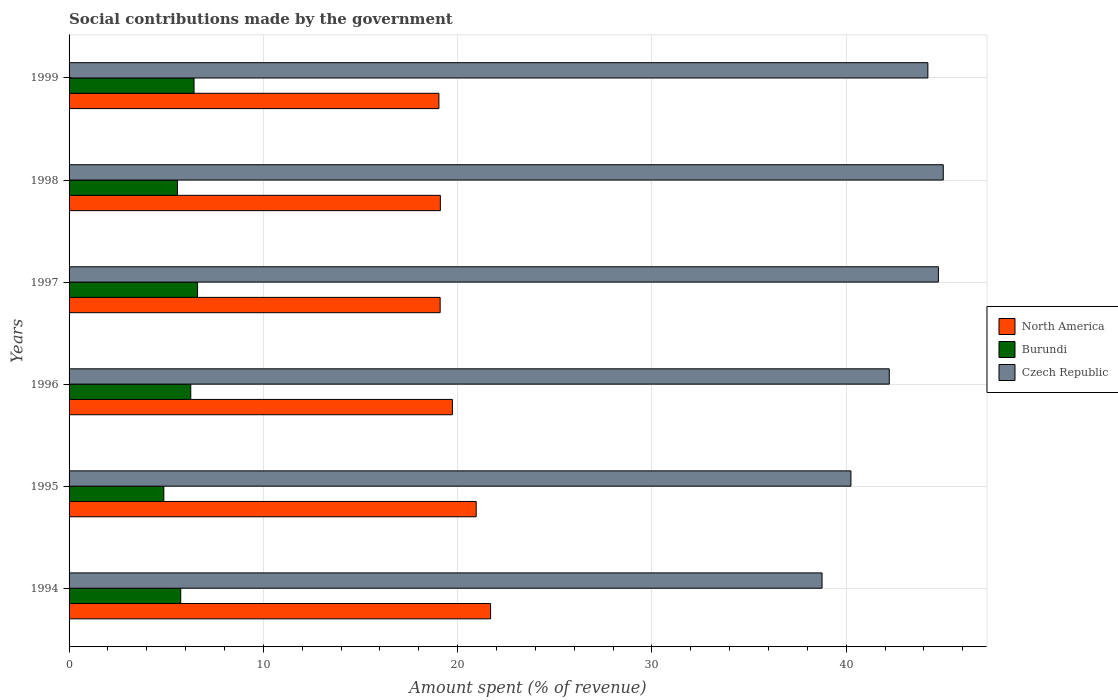How many different coloured bars are there?
Ensure brevity in your answer.  3. How many groups of bars are there?
Offer a very short reply. 6. Are the number of bars per tick equal to the number of legend labels?
Provide a succinct answer. Yes. What is the label of the 6th group of bars from the top?
Offer a terse response. 1994. In how many cases, is the number of bars for a given year not equal to the number of legend labels?
Keep it short and to the point. 0. What is the amount spent (in %) on social contributions in North America in 1996?
Ensure brevity in your answer.  19.73. Across all years, what is the maximum amount spent (in %) on social contributions in North America?
Your response must be concise. 21.69. Across all years, what is the minimum amount spent (in %) on social contributions in Czech Republic?
Provide a short and direct response. 38.75. In which year was the amount spent (in %) on social contributions in North America maximum?
Offer a terse response. 1994. In which year was the amount spent (in %) on social contributions in Czech Republic minimum?
Make the answer very short. 1994. What is the total amount spent (in %) on social contributions in Czech Republic in the graph?
Ensure brevity in your answer.  255.15. What is the difference between the amount spent (in %) on social contributions in Burundi in 1994 and that in 1996?
Your response must be concise. -0.52. What is the difference between the amount spent (in %) on social contributions in Czech Republic in 1996 and the amount spent (in %) on social contributions in Burundi in 1997?
Make the answer very short. 35.6. What is the average amount spent (in %) on social contributions in Burundi per year?
Your response must be concise. 5.92. In the year 1999, what is the difference between the amount spent (in %) on social contributions in Burundi and amount spent (in %) on social contributions in Czech Republic?
Offer a very short reply. -37.77. In how many years, is the amount spent (in %) on social contributions in Czech Republic greater than 24 %?
Make the answer very short. 6. What is the ratio of the amount spent (in %) on social contributions in Burundi in 1994 to that in 1996?
Your response must be concise. 0.92. Is the amount spent (in %) on social contributions in Burundi in 1994 less than that in 1996?
Provide a succinct answer. Yes. What is the difference between the highest and the second highest amount spent (in %) on social contributions in Burundi?
Your response must be concise. 0.18. What is the difference between the highest and the lowest amount spent (in %) on social contributions in Czech Republic?
Provide a short and direct response. 6.24. What does the 1st bar from the top in 1999 represents?
Provide a short and direct response. Czech Republic. Is it the case that in every year, the sum of the amount spent (in %) on social contributions in Burundi and amount spent (in %) on social contributions in North America is greater than the amount spent (in %) on social contributions in Czech Republic?
Provide a succinct answer. No. How many years are there in the graph?
Offer a terse response. 6. What is the difference between two consecutive major ticks on the X-axis?
Provide a short and direct response. 10. Are the values on the major ticks of X-axis written in scientific E-notation?
Give a very brief answer. No. Does the graph contain any zero values?
Offer a terse response. No. Does the graph contain grids?
Ensure brevity in your answer.  Yes. What is the title of the graph?
Provide a succinct answer. Social contributions made by the government. Does "Dominican Republic" appear as one of the legend labels in the graph?
Your answer should be compact. No. What is the label or title of the X-axis?
Make the answer very short. Amount spent (% of revenue). What is the label or title of the Y-axis?
Your answer should be compact. Years. What is the Amount spent (% of revenue) of North America in 1994?
Your answer should be compact. 21.69. What is the Amount spent (% of revenue) in Burundi in 1994?
Ensure brevity in your answer.  5.75. What is the Amount spent (% of revenue) of Czech Republic in 1994?
Your response must be concise. 38.75. What is the Amount spent (% of revenue) of North America in 1995?
Offer a very short reply. 20.95. What is the Amount spent (% of revenue) of Burundi in 1995?
Keep it short and to the point. 4.88. What is the Amount spent (% of revenue) of Czech Republic in 1995?
Provide a short and direct response. 40.24. What is the Amount spent (% of revenue) of North America in 1996?
Keep it short and to the point. 19.73. What is the Amount spent (% of revenue) of Burundi in 1996?
Your answer should be compact. 6.26. What is the Amount spent (% of revenue) in Czech Republic in 1996?
Your response must be concise. 42.22. What is the Amount spent (% of revenue) of North America in 1997?
Your answer should be compact. 19.1. What is the Amount spent (% of revenue) in Burundi in 1997?
Keep it short and to the point. 6.61. What is the Amount spent (% of revenue) in Czech Republic in 1997?
Provide a short and direct response. 44.74. What is the Amount spent (% of revenue) in North America in 1998?
Your answer should be very brief. 19.11. What is the Amount spent (% of revenue) of Burundi in 1998?
Offer a very short reply. 5.58. What is the Amount spent (% of revenue) of Czech Republic in 1998?
Your response must be concise. 44.99. What is the Amount spent (% of revenue) in North America in 1999?
Provide a succinct answer. 19.03. What is the Amount spent (% of revenue) of Burundi in 1999?
Your answer should be compact. 6.43. What is the Amount spent (% of revenue) of Czech Republic in 1999?
Provide a short and direct response. 44.2. Across all years, what is the maximum Amount spent (% of revenue) in North America?
Keep it short and to the point. 21.69. Across all years, what is the maximum Amount spent (% of revenue) in Burundi?
Offer a terse response. 6.61. Across all years, what is the maximum Amount spent (% of revenue) in Czech Republic?
Offer a terse response. 44.99. Across all years, what is the minimum Amount spent (% of revenue) of North America?
Keep it short and to the point. 19.03. Across all years, what is the minimum Amount spent (% of revenue) of Burundi?
Your response must be concise. 4.88. Across all years, what is the minimum Amount spent (% of revenue) in Czech Republic?
Offer a terse response. 38.75. What is the total Amount spent (% of revenue) in North America in the graph?
Your answer should be very brief. 119.62. What is the total Amount spent (% of revenue) in Burundi in the graph?
Make the answer very short. 35.51. What is the total Amount spent (% of revenue) of Czech Republic in the graph?
Ensure brevity in your answer.  255.15. What is the difference between the Amount spent (% of revenue) in North America in 1994 and that in 1995?
Make the answer very short. 0.74. What is the difference between the Amount spent (% of revenue) in Burundi in 1994 and that in 1995?
Provide a short and direct response. 0.87. What is the difference between the Amount spent (% of revenue) in Czech Republic in 1994 and that in 1995?
Provide a succinct answer. -1.49. What is the difference between the Amount spent (% of revenue) of North America in 1994 and that in 1996?
Offer a terse response. 1.97. What is the difference between the Amount spent (% of revenue) of Burundi in 1994 and that in 1996?
Provide a succinct answer. -0.52. What is the difference between the Amount spent (% of revenue) in Czech Republic in 1994 and that in 1996?
Keep it short and to the point. -3.46. What is the difference between the Amount spent (% of revenue) in North America in 1994 and that in 1997?
Offer a terse response. 2.59. What is the difference between the Amount spent (% of revenue) in Burundi in 1994 and that in 1997?
Provide a succinct answer. -0.87. What is the difference between the Amount spent (% of revenue) of Czech Republic in 1994 and that in 1997?
Ensure brevity in your answer.  -5.99. What is the difference between the Amount spent (% of revenue) in North America in 1994 and that in 1998?
Keep it short and to the point. 2.58. What is the difference between the Amount spent (% of revenue) of Burundi in 1994 and that in 1998?
Keep it short and to the point. 0.17. What is the difference between the Amount spent (% of revenue) in Czech Republic in 1994 and that in 1998?
Your answer should be very brief. -6.24. What is the difference between the Amount spent (% of revenue) in North America in 1994 and that in 1999?
Make the answer very short. 2.66. What is the difference between the Amount spent (% of revenue) of Burundi in 1994 and that in 1999?
Your response must be concise. -0.68. What is the difference between the Amount spent (% of revenue) of Czech Republic in 1994 and that in 1999?
Provide a short and direct response. -5.45. What is the difference between the Amount spent (% of revenue) in North America in 1995 and that in 1996?
Keep it short and to the point. 1.23. What is the difference between the Amount spent (% of revenue) of Burundi in 1995 and that in 1996?
Offer a terse response. -1.39. What is the difference between the Amount spent (% of revenue) of Czech Republic in 1995 and that in 1996?
Offer a very short reply. -1.97. What is the difference between the Amount spent (% of revenue) of North America in 1995 and that in 1997?
Provide a succinct answer. 1.86. What is the difference between the Amount spent (% of revenue) in Burundi in 1995 and that in 1997?
Ensure brevity in your answer.  -1.74. What is the difference between the Amount spent (% of revenue) in Czech Republic in 1995 and that in 1997?
Give a very brief answer. -4.5. What is the difference between the Amount spent (% of revenue) in North America in 1995 and that in 1998?
Offer a very short reply. 1.85. What is the difference between the Amount spent (% of revenue) of Burundi in 1995 and that in 1998?
Provide a succinct answer. -0.7. What is the difference between the Amount spent (% of revenue) of Czech Republic in 1995 and that in 1998?
Your response must be concise. -4.75. What is the difference between the Amount spent (% of revenue) of North America in 1995 and that in 1999?
Your response must be concise. 1.92. What is the difference between the Amount spent (% of revenue) in Burundi in 1995 and that in 1999?
Ensure brevity in your answer.  -1.56. What is the difference between the Amount spent (% of revenue) of Czech Republic in 1995 and that in 1999?
Provide a short and direct response. -3.96. What is the difference between the Amount spent (% of revenue) of North America in 1996 and that in 1997?
Offer a very short reply. 0.63. What is the difference between the Amount spent (% of revenue) of Burundi in 1996 and that in 1997?
Your answer should be compact. -0.35. What is the difference between the Amount spent (% of revenue) of Czech Republic in 1996 and that in 1997?
Your answer should be very brief. -2.53. What is the difference between the Amount spent (% of revenue) in North America in 1996 and that in 1998?
Ensure brevity in your answer.  0.62. What is the difference between the Amount spent (% of revenue) of Burundi in 1996 and that in 1998?
Your answer should be very brief. 0.68. What is the difference between the Amount spent (% of revenue) in Czech Republic in 1996 and that in 1998?
Make the answer very short. -2.78. What is the difference between the Amount spent (% of revenue) in North America in 1996 and that in 1999?
Give a very brief answer. 0.69. What is the difference between the Amount spent (% of revenue) in Burundi in 1996 and that in 1999?
Offer a very short reply. -0.17. What is the difference between the Amount spent (% of revenue) of Czech Republic in 1996 and that in 1999?
Provide a short and direct response. -1.99. What is the difference between the Amount spent (% of revenue) of North America in 1997 and that in 1998?
Keep it short and to the point. -0.01. What is the difference between the Amount spent (% of revenue) of Burundi in 1997 and that in 1998?
Provide a succinct answer. 1.03. What is the difference between the Amount spent (% of revenue) in Czech Republic in 1997 and that in 1998?
Offer a terse response. -0.25. What is the difference between the Amount spent (% of revenue) of North America in 1997 and that in 1999?
Keep it short and to the point. 0.06. What is the difference between the Amount spent (% of revenue) of Burundi in 1997 and that in 1999?
Your response must be concise. 0.18. What is the difference between the Amount spent (% of revenue) in Czech Republic in 1997 and that in 1999?
Provide a succinct answer. 0.54. What is the difference between the Amount spent (% of revenue) in North America in 1998 and that in 1999?
Ensure brevity in your answer.  0.07. What is the difference between the Amount spent (% of revenue) of Burundi in 1998 and that in 1999?
Offer a terse response. -0.85. What is the difference between the Amount spent (% of revenue) in Czech Republic in 1998 and that in 1999?
Your response must be concise. 0.79. What is the difference between the Amount spent (% of revenue) in North America in 1994 and the Amount spent (% of revenue) in Burundi in 1995?
Keep it short and to the point. 16.82. What is the difference between the Amount spent (% of revenue) in North America in 1994 and the Amount spent (% of revenue) in Czech Republic in 1995?
Ensure brevity in your answer.  -18.55. What is the difference between the Amount spent (% of revenue) of Burundi in 1994 and the Amount spent (% of revenue) of Czech Republic in 1995?
Keep it short and to the point. -34.49. What is the difference between the Amount spent (% of revenue) in North America in 1994 and the Amount spent (% of revenue) in Burundi in 1996?
Give a very brief answer. 15.43. What is the difference between the Amount spent (% of revenue) in North America in 1994 and the Amount spent (% of revenue) in Czech Republic in 1996?
Offer a very short reply. -20.52. What is the difference between the Amount spent (% of revenue) in Burundi in 1994 and the Amount spent (% of revenue) in Czech Republic in 1996?
Ensure brevity in your answer.  -36.47. What is the difference between the Amount spent (% of revenue) in North America in 1994 and the Amount spent (% of revenue) in Burundi in 1997?
Your answer should be very brief. 15.08. What is the difference between the Amount spent (% of revenue) of North America in 1994 and the Amount spent (% of revenue) of Czech Republic in 1997?
Provide a succinct answer. -23.05. What is the difference between the Amount spent (% of revenue) of Burundi in 1994 and the Amount spent (% of revenue) of Czech Republic in 1997?
Your response must be concise. -39. What is the difference between the Amount spent (% of revenue) of North America in 1994 and the Amount spent (% of revenue) of Burundi in 1998?
Ensure brevity in your answer.  16.12. What is the difference between the Amount spent (% of revenue) in North America in 1994 and the Amount spent (% of revenue) in Czech Republic in 1998?
Give a very brief answer. -23.3. What is the difference between the Amount spent (% of revenue) of Burundi in 1994 and the Amount spent (% of revenue) of Czech Republic in 1998?
Give a very brief answer. -39.25. What is the difference between the Amount spent (% of revenue) of North America in 1994 and the Amount spent (% of revenue) of Burundi in 1999?
Give a very brief answer. 15.26. What is the difference between the Amount spent (% of revenue) of North America in 1994 and the Amount spent (% of revenue) of Czech Republic in 1999?
Your answer should be compact. -22.51. What is the difference between the Amount spent (% of revenue) in Burundi in 1994 and the Amount spent (% of revenue) in Czech Republic in 1999?
Offer a very short reply. -38.45. What is the difference between the Amount spent (% of revenue) in North America in 1995 and the Amount spent (% of revenue) in Burundi in 1996?
Ensure brevity in your answer.  14.69. What is the difference between the Amount spent (% of revenue) of North America in 1995 and the Amount spent (% of revenue) of Czech Republic in 1996?
Give a very brief answer. -21.26. What is the difference between the Amount spent (% of revenue) of Burundi in 1995 and the Amount spent (% of revenue) of Czech Republic in 1996?
Make the answer very short. -37.34. What is the difference between the Amount spent (% of revenue) in North America in 1995 and the Amount spent (% of revenue) in Burundi in 1997?
Ensure brevity in your answer.  14.34. What is the difference between the Amount spent (% of revenue) of North America in 1995 and the Amount spent (% of revenue) of Czech Republic in 1997?
Your response must be concise. -23.79. What is the difference between the Amount spent (% of revenue) in Burundi in 1995 and the Amount spent (% of revenue) in Czech Republic in 1997?
Give a very brief answer. -39.87. What is the difference between the Amount spent (% of revenue) of North America in 1995 and the Amount spent (% of revenue) of Burundi in 1998?
Provide a short and direct response. 15.38. What is the difference between the Amount spent (% of revenue) of North America in 1995 and the Amount spent (% of revenue) of Czech Republic in 1998?
Provide a short and direct response. -24.04. What is the difference between the Amount spent (% of revenue) of Burundi in 1995 and the Amount spent (% of revenue) of Czech Republic in 1998?
Provide a succinct answer. -40.12. What is the difference between the Amount spent (% of revenue) of North America in 1995 and the Amount spent (% of revenue) of Burundi in 1999?
Offer a very short reply. 14.52. What is the difference between the Amount spent (% of revenue) of North America in 1995 and the Amount spent (% of revenue) of Czech Republic in 1999?
Your response must be concise. -23.25. What is the difference between the Amount spent (% of revenue) of Burundi in 1995 and the Amount spent (% of revenue) of Czech Republic in 1999?
Offer a terse response. -39.32. What is the difference between the Amount spent (% of revenue) in North America in 1996 and the Amount spent (% of revenue) in Burundi in 1997?
Keep it short and to the point. 13.12. What is the difference between the Amount spent (% of revenue) of North America in 1996 and the Amount spent (% of revenue) of Czech Republic in 1997?
Your response must be concise. -25.01. What is the difference between the Amount spent (% of revenue) of Burundi in 1996 and the Amount spent (% of revenue) of Czech Republic in 1997?
Offer a terse response. -38.48. What is the difference between the Amount spent (% of revenue) of North America in 1996 and the Amount spent (% of revenue) of Burundi in 1998?
Your answer should be compact. 14.15. What is the difference between the Amount spent (% of revenue) of North America in 1996 and the Amount spent (% of revenue) of Czech Republic in 1998?
Your answer should be very brief. -25.26. What is the difference between the Amount spent (% of revenue) of Burundi in 1996 and the Amount spent (% of revenue) of Czech Republic in 1998?
Your response must be concise. -38.73. What is the difference between the Amount spent (% of revenue) of North America in 1996 and the Amount spent (% of revenue) of Burundi in 1999?
Offer a very short reply. 13.3. What is the difference between the Amount spent (% of revenue) in North America in 1996 and the Amount spent (% of revenue) in Czech Republic in 1999?
Your answer should be compact. -24.47. What is the difference between the Amount spent (% of revenue) of Burundi in 1996 and the Amount spent (% of revenue) of Czech Republic in 1999?
Make the answer very short. -37.94. What is the difference between the Amount spent (% of revenue) of North America in 1997 and the Amount spent (% of revenue) of Burundi in 1998?
Provide a short and direct response. 13.52. What is the difference between the Amount spent (% of revenue) of North America in 1997 and the Amount spent (% of revenue) of Czech Republic in 1998?
Offer a terse response. -25.89. What is the difference between the Amount spent (% of revenue) in Burundi in 1997 and the Amount spent (% of revenue) in Czech Republic in 1998?
Ensure brevity in your answer.  -38.38. What is the difference between the Amount spent (% of revenue) in North America in 1997 and the Amount spent (% of revenue) in Burundi in 1999?
Keep it short and to the point. 12.67. What is the difference between the Amount spent (% of revenue) of North America in 1997 and the Amount spent (% of revenue) of Czech Republic in 1999?
Your response must be concise. -25.1. What is the difference between the Amount spent (% of revenue) of Burundi in 1997 and the Amount spent (% of revenue) of Czech Republic in 1999?
Your answer should be compact. -37.59. What is the difference between the Amount spent (% of revenue) in North America in 1998 and the Amount spent (% of revenue) in Burundi in 1999?
Offer a very short reply. 12.68. What is the difference between the Amount spent (% of revenue) of North America in 1998 and the Amount spent (% of revenue) of Czech Republic in 1999?
Offer a terse response. -25.09. What is the difference between the Amount spent (% of revenue) of Burundi in 1998 and the Amount spent (% of revenue) of Czech Republic in 1999?
Keep it short and to the point. -38.62. What is the average Amount spent (% of revenue) of North America per year?
Give a very brief answer. 19.94. What is the average Amount spent (% of revenue) in Burundi per year?
Offer a very short reply. 5.92. What is the average Amount spent (% of revenue) of Czech Republic per year?
Your answer should be very brief. 42.52. In the year 1994, what is the difference between the Amount spent (% of revenue) of North America and Amount spent (% of revenue) of Burundi?
Offer a very short reply. 15.95. In the year 1994, what is the difference between the Amount spent (% of revenue) in North America and Amount spent (% of revenue) in Czech Republic?
Make the answer very short. -17.06. In the year 1994, what is the difference between the Amount spent (% of revenue) of Burundi and Amount spent (% of revenue) of Czech Republic?
Keep it short and to the point. -33.01. In the year 1995, what is the difference between the Amount spent (% of revenue) in North America and Amount spent (% of revenue) in Burundi?
Your response must be concise. 16.08. In the year 1995, what is the difference between the Amount spent (% of revenue) in North America and Amount spent (% of revenue) in Czech Republic?
Give a very brief answer. -19.29. In the year 1995, what is the difference between the Amount spent (% of revenue) in Burundi and Amount spent (% of revenue) in Czech Republic?
Provide a succinct answer. -35.36. In the year 1996, what is the difference between the Amount spent (% of revenue) of North America and Amount spent (% of revenue) of Burundi?
Offer a very short reply. 13.47. In the year 1996, what is the difference between the Amount spent (% of revenue) of North America and Amount spent (% of revenue) of Czech Republic?
Give a very brief answer. -22.49. In the year 1996, what is the difference between the Amount spent (% of revenue) of Burundi and Amount spent (% of revenue) of Czech Republic?
Offer a very short reply. -35.95. In the year 1997, what is the difference between the Amount spent (% of revenue) of North America and Amount spent (% of revenue) of Burundi?
Offer a terse response. 12.49. In the year 1997, what is the difference between the Amount spent (% of revenue) of North America and Amount spent (% of revenue) of Czech Republic?
Ensure brevity in your answer.  -25.64. In the year 1997, what is the difference between the Amount spent (% of revenue) of Burundi and Amount spent (% of revenue) of Czech Republic?
Provide a succinct answer. -38.13. In the year 1998, what is the difference between the Amount spent (% of revenue) of North America and Amount spent (% of revenue) of Burundi?
Provide a succinct answer. 13.53. In the year 1998, what is the difference between the Amount spent (% of revenue) of North America and Amount spent (% of revenue) of Czech Republic?
Offer a terse response. -25.88. In the year 1998, what is the difference between the Amount spent (% of revenue) of Burundi and Amount spent (% of revenue) of Czech Republic?
Provide a short and direct response. -39.41. In the year 1999, what is the difference between the Amount spent (% of revenue) of North America and Amount spent (% of revenue) of Burundi?
Keep it short and to the point. 12.6. In the year 1999, what is the difference between the Amount spent (% of revenue) of North America and Amount spent (% of revenue) of Czech Republic?
Your answer should be compact. -25.17. In the year 1999, what is the difference between the Amount spent (% of revenue) in Burundi and Amount spent (% of revenue) in Czech Republic?
Offer a very short reply. -37.77. What is the ratio of the Amount spent (% of revenue) in North America in 1994 to that in 1995?
Provide a succinct answer. 1.04. What is the ratio of the Amount spent (% of revenue) in Burundi in 1994 to that in 1995?
Give a very brief answer. 1.18. What is the ratio of the Amount spent (% of revenue) of Czech Republic in 1994 to that in 1995?
Offer a very short reply. 0.96. What is the ratio of the Amount spent (% of revenue) in North America in 1994 to that in 1996?
Your answer should be very brief. 1.1. What is the ratio of the Amount spent (% of revenue) of Burundi in 1994 to that in 1996?
Your answer should be very brief. 0.92. What is the ratio of the Amount spent (% of revenue) in Czech Republic in 1994 to that in 1996?
Offer a very short reply. 0.92. What is the ratio of the Amount spent (% of revenue) of North America in 1994 to that in 1997?
Offer a very short reply. 1.14. What is the ratio of the Amount spent (% of revenue) of Burundi in 1994 to that in 1997?
Keep it short and to the point. 0.87. What is the ratio of the Amount spent (% of revenue) of Czech Republic in 1994 to that in 1997?
Make the answer very short. 0.87. What is the ratio of the Amount spent (% of revenue) in North America in 1994 to that in 1998?
Give a very brief answer. 1.14. What is the ratio of the Amount spent (% of revenue) in Burundi in 1994 to that in 1998?
Your answer should be very brief. 1.03. What is the ratio of the Amount spent (% of revenue) in Czech Republic in 1994 to that in 1998?
Keep it short and to the point. 0.86. What is the ratio of the Amount spent (% of revenue) in North America in 1994 to that in 1999?
Provide a short and direct response. 1.14. What is the ratio of the Amount spent (% of revenue) of Burundi in 1994 to that in 1999?
Your answer should be compact. 0.89. What is the ratio of the Amount spent (% of revenue) in Czech Republic in 1994 to that in 1999?
Provide a succinct answer. 0.88. What is the ratio of the Amount spent (% of revenue) in North America in 1995 to that in 1996?
Provide a short and direct response. 1.06. What is the ratio of the Amount spent (% of revenue) in Burundi in 1995 to that in 1996?
Provide a short and direct response. 0.78. What is the ratio of the Amount spent (% of revenue) in Czech Republic in 1995 to that in 1996?
Keep it short and to the point. 0.95. What is the ratio of the Amount spent (% of revenue) in North America in 1995 to that in 1997?
Keep it short and to the point. 1.1. What is the ratio of the Amount spent (% of revenue) of Burundi in 1995 to that in 1997?
Your response must be concise. 0.74. What is the ratio of the Amount spent (% of revenue) of Czech Republic in 1995 to that in 1997?
Ensure brevity in your answer.  0.9. What is the ratio of the Amount spent (% of revenue) in North America in 1995 to that in 1998?
Keep it short and to the point. 1.1. What is the ratio of the Amount spent (% of revenue) in Burundi in 1995 to that in 1998?
Ensure brevity in your answer.  0.87. What is the ratio of the Amount spent (% of revenue) of Czech Republic in 1995 to that in 1998?
Provide a short and direct response. 0.89. What is the ratio of the Amount spent (% of revenue) of North America in 1995 to that in 1999?
Give a very brief answer. 1.1. What is the ratio of the Amount spent (% of revenue) in Burundi in 1995 to that in 1999?
Ensure brevity in your answer.  0.76. What is the ratio of the Amount spent (% of revenue) in Czech Republic in 1995 to that in 1999?
Give a very brief answer. 0.91. What is the ratio of the Amount spent (% of revenue) in North America in 1996 to that in 1997?
Offer a very short reply. 1.03. What is the ratio of the Amount spent (% of revenue) in Burundi in 1996 to that in 1997?
Your answer should be compact. 0.95. What is the ratio of the Amount spent (% of revenue) of Czech Republic in 1996 to that in 1997?
Make the answer very short. 0.94. What is the ratio of the Amount spent (% of revenue) in North America in 1996 to that in 1998?
Provide a succinct answer. 1.03. What is the ratio of the Amount spent (% of revenue) in Burundi in 1996 to that in 1998?
Ensure brevity in your answer.  1.12. What is the ratio of the Amount spent (% of revenue) of Czech Republic in 1996 to that in 1998?
Provide a succinct answer. 0.94. What is the ratio of the Amount spent (% of revenue) in North America in 1996 to that in 1999?
Ensure brevity in your answer.  1.04. What is the ratio of the Amount spent (% of revenue) of Burundi in 1996 to that in 1999?
Provide a short and direct response. 0.97. What is the ratio of the Amount spent (% of revenue) of Czech Republic in 1996 to that in 1999?
Provide a succinct answer. 0.96. What is the ratio of the Amount spent (% of revenue) in Burundi in 1997 to that in 1998?
Provide a succinct answer. 1.19. What is the ratio of the Amount spent (% of revenue) of Czech Republic in 1997 to that in 1998?
Make the answer very short. 0.99. What is the ratio of the Amount spent (% of revenue) in Burundi in 1997 to that in 1999?
Make the answer very short. 1.03. What is the ratio of the Amount spent (% of revenue) of Czech Republic in 1997 to that in 1999?
Offer a very short reply. 1.01. What is the ratio of the Amount spent (% of revenue) in North America in 1998 to that in 1999?
Offer a terse response. 1. What is the ratio of the Amount spent (% of revenue) of Burundi in 1998 to that in 1999?
Provide a short and direct response. 0.87. What is the ratio of the Amount spent (% of revenue) of Czech Republic in 1998 to that in 1999?
Your answer should be compact. 1.02. What is the difference between the highest and the second highest Amount spent (% of revenue) of North America?
Make the answer very short. 0.74. What is the difference between the highest and the second highest Amount spent (% of revenue) of Burundi?
Provide a short and direct response. 0.18. What is the difference between the highest and the second highest Amount spent (% of revenue) in Czech Republic?
Your answer should be compact. 0.25. What is the difference between the highest and the lowest Amount spent (% of revenue) of North America?
Your answer should be very brief. 2.66. What is the difference between the highest and the lowest Amount spent (% of revenue) of Burundi?
Provide a short and direct response. 1.74. What is the difference between the highest and the lowest Amount spent (% of revenue) in Czech Republic?
Keep it short and to the point. 6.24. 